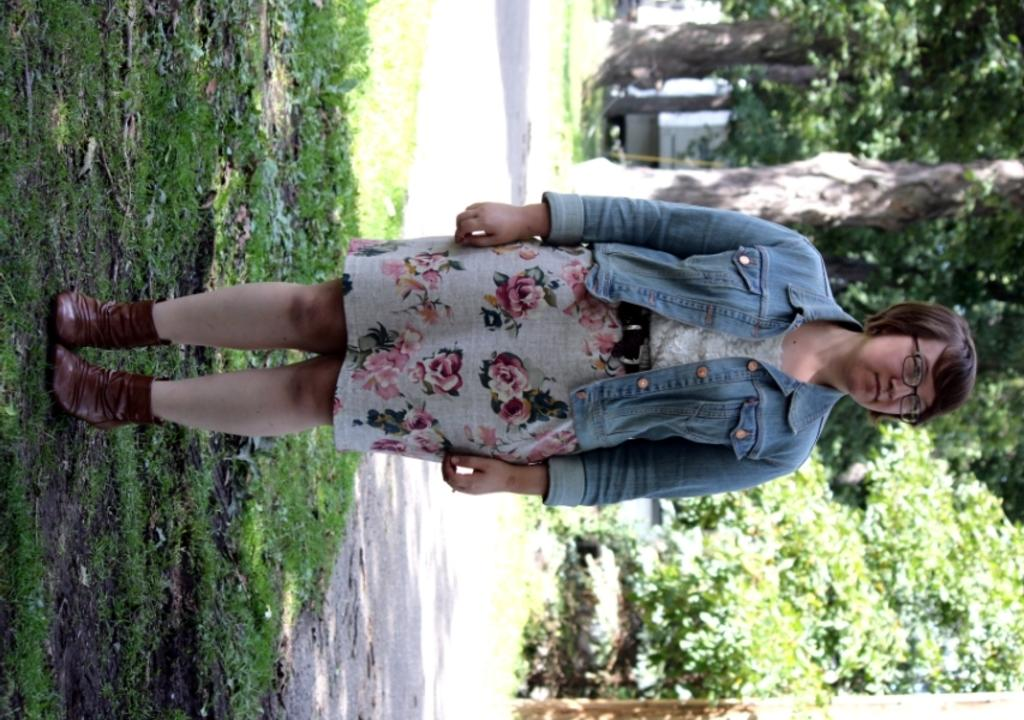Who is the main subject in the image? There is a woman in the image. What is the woman standing on? The woman is standing on the grass. What is the woman wearing? The woman is wearing a jacket and glasses. What can be seen in the background of the image? There are trees and a road in the background of the image. What type of company is the woman representing in the image? There is no indication in the image that the woman is representing a company. What is the shape of the woman's chin in the image? The shape of the woman's chin cannot be determined from the image, as it is not visible. 